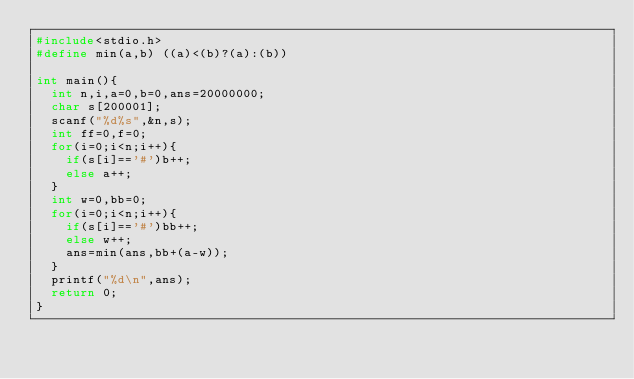Convert code to text. <code><loc_0><loc_0><loc_500><loc_500><_C_>#include<stdio.h>
#define min(a,b) ((a)<(b)?(a):(b))

int main(){
	int n,i,a=0,b=0,ans=20000000;
	char s[200001];
	scanf("%d%s",&n,s);
	int ff=0,f=0;
	for(i=0;i<n;i++){
		if(s[i]=='#')b++;
		else a++;
	}
	int w=0,bb=0;
	for(i=0;i<n;i++){
		if(s[i]=='#')bb++;
		else w++;
		ans=min(ans,bb+(a-w));
	}
	printf("%d\n",ans);
	return 0;
}</code> 